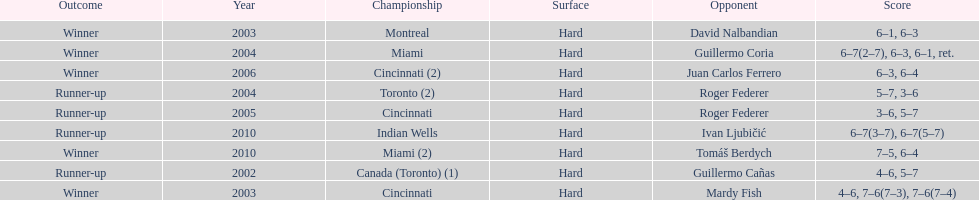How many times was the championship in miami? 2. 